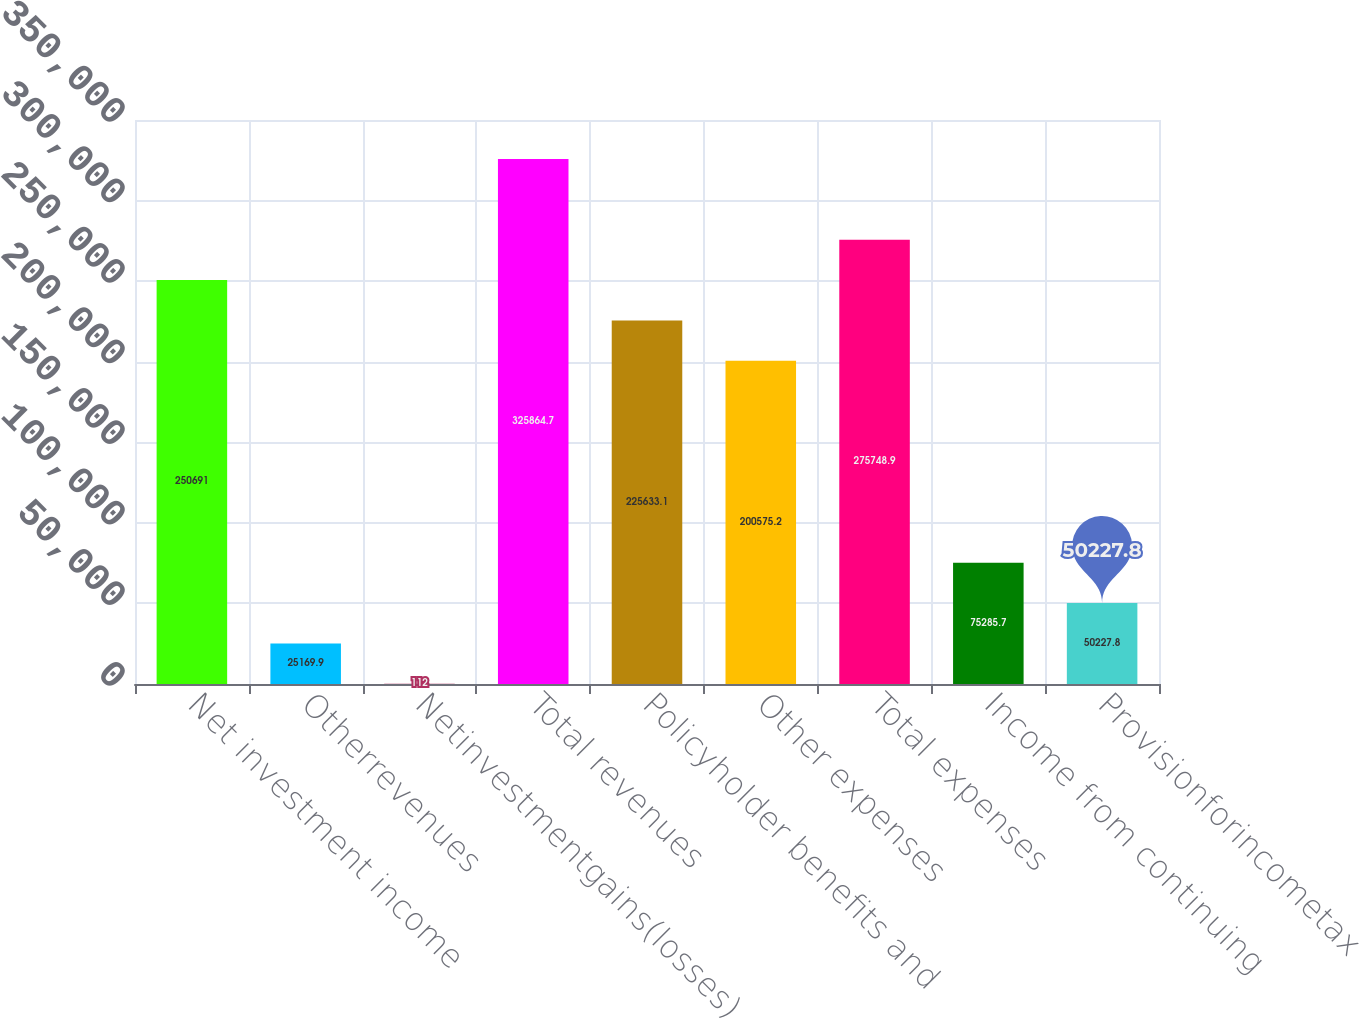<chart> <loc_0><loc_0><loc_500><loc_500><bar_chart><fcel>Net investment income<fcel>Otherrevenues<fcel>Netinvestmentgains(losses)<fcel>Total revenues<fcel>Policyholder benefits and<fcel>Other expenses<fcel>Total expenses<fcel>Income from continuing<fcel>Provisionforincometax<nl><fcel>250691<fcel>25169.9<fcel>112<fcel>325865<fcel>225633<fcel>200575<fcel>275749<fcel>75285.7<fcel>50227.8<nl></chart> 